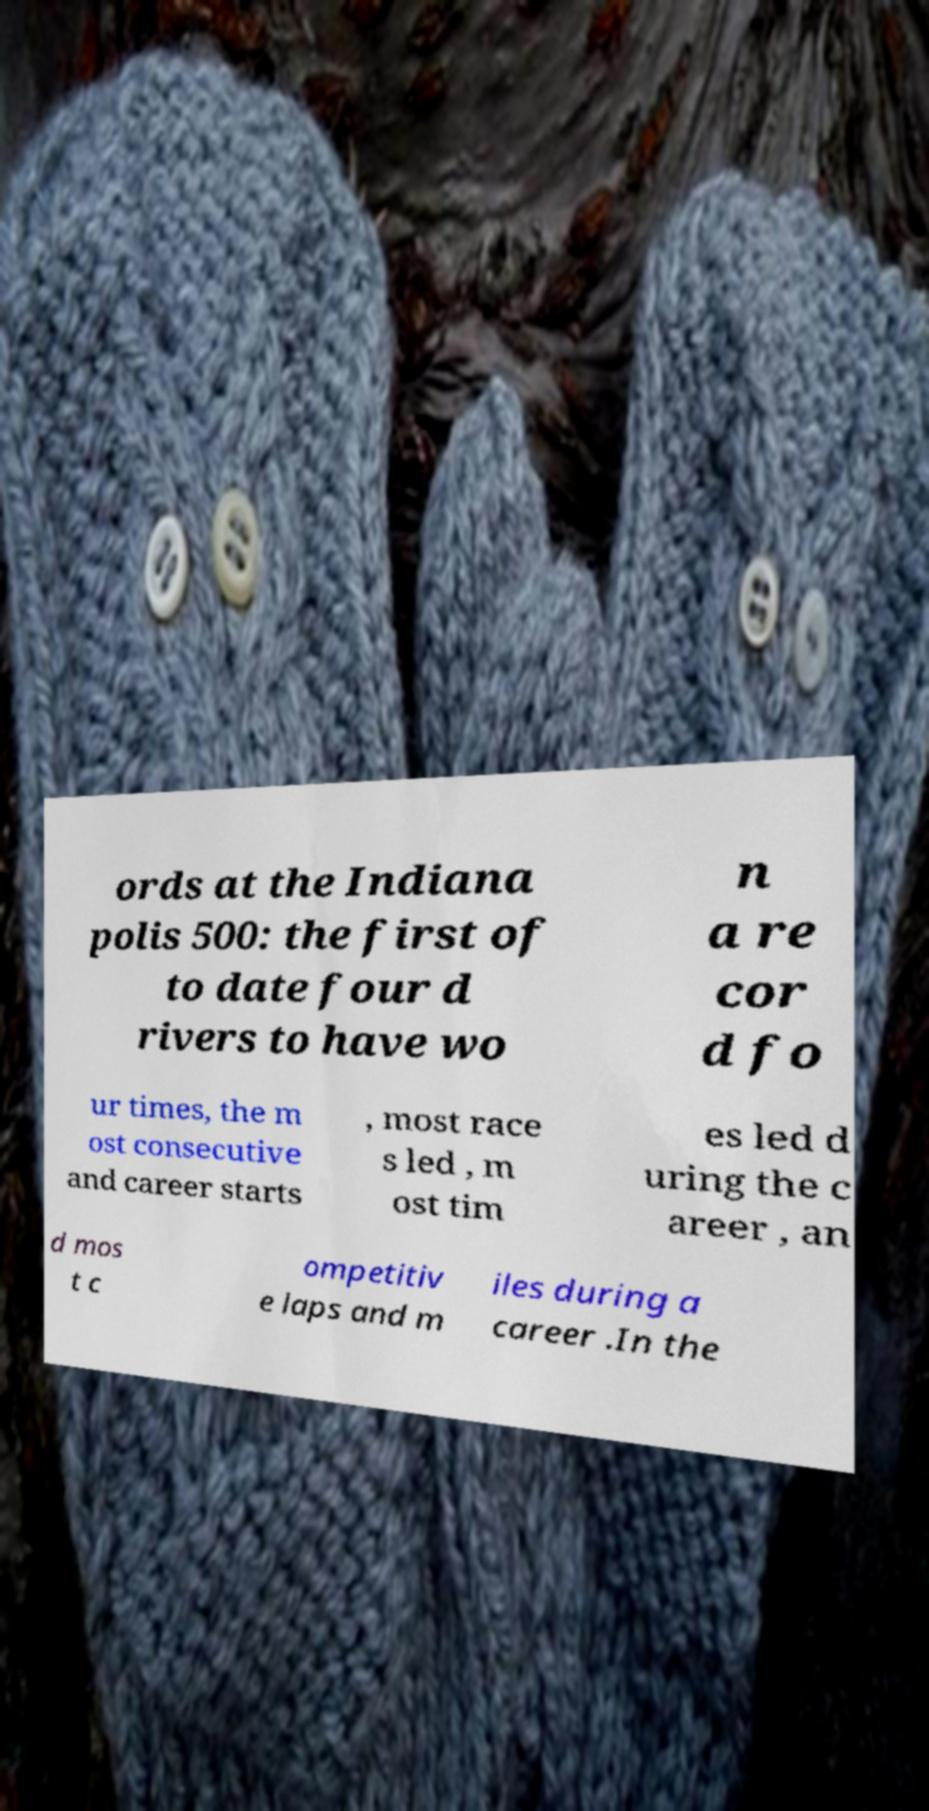Could you assist in decoding the text presented in this image and type it out clearly? ords at the Indiana polis 500: the first of to date four d rivers to have wo n a re cor d fo ur times, the m ost consecutive and career starts , most race s led , m ost tim es led d uring the c areer , an d mos t c ompetitiv e laps and m iles during a career .In the 